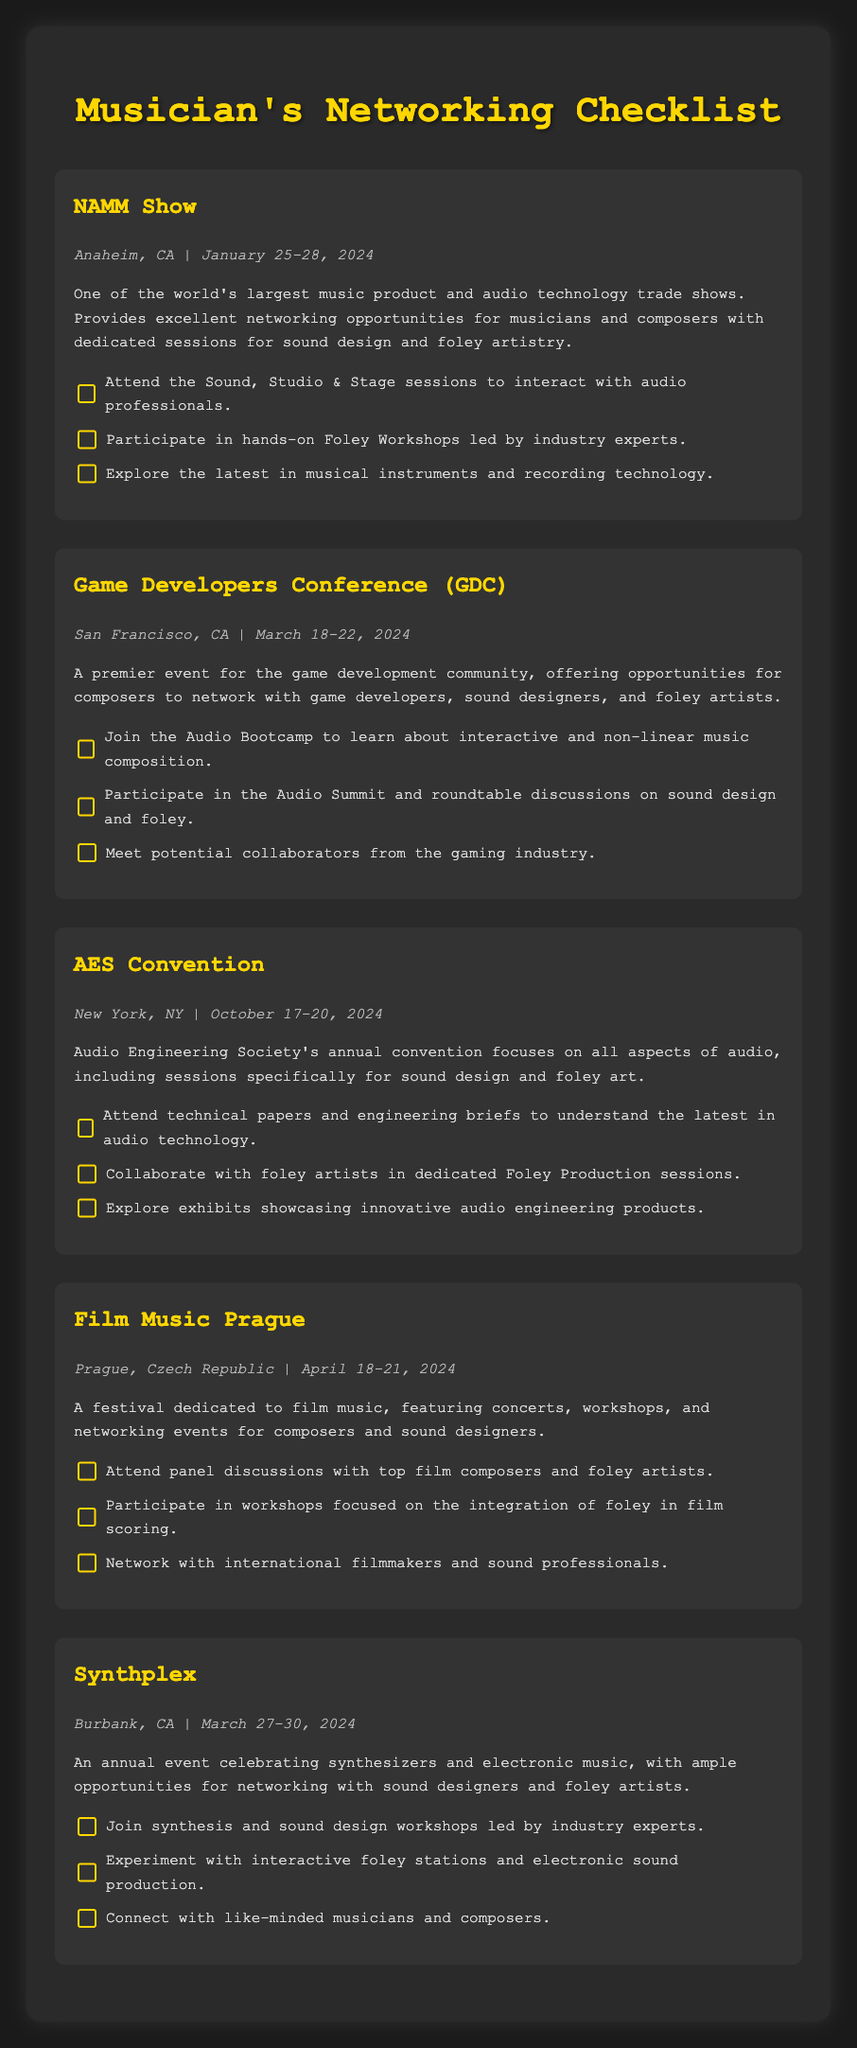What is the date for the NAMM Show? The date for the NAMM Show is provided in the event details section, which states January 25-28, 2024.
Answer: January 25-28, 2024 Which city will host the Game Developers Conference? The city hosting the Game Developers Conference is found in the event details section, which indicates San Francisco, CA.
Answer: San Francisco, CA What is a type of workshop offered at the AES Convention? The AES Convention includes dedicated Foley Production sessions, as mentioned in the checklist section.
Answer: Foley Production sessions How many events are listed in the document? The number of events can be counted by reviewing the document during analysis; there are five events listed.
Answer: 5 What will attendees learn about in the Audio Bootcamp at GDC? The Audio Bootcamp at GDC focuses on interactive and non-linear music composition, according to the checklist.
Answer: Interactive and non-linear music composition Which foley-related activity can be found at Film Music Prague? Film Music Prague features workshops focused on the integration of foley in film scoring, which is stated in the description.
Answer: Integration of foley in film scoring What is the main focus of Synthplex? The main focus of Synthplex, as described, is the celebration of synthesizers and electronic music.
Answer: Synthesizers and electronic music What is one of the goals of attending the Sound, Studio & Stage sessions at NAMM? Attending Sound, Studio & Stage sessions aims to interact with audio professionals, as mentioned in the checklist.
Answer: Interact with audio professionals 